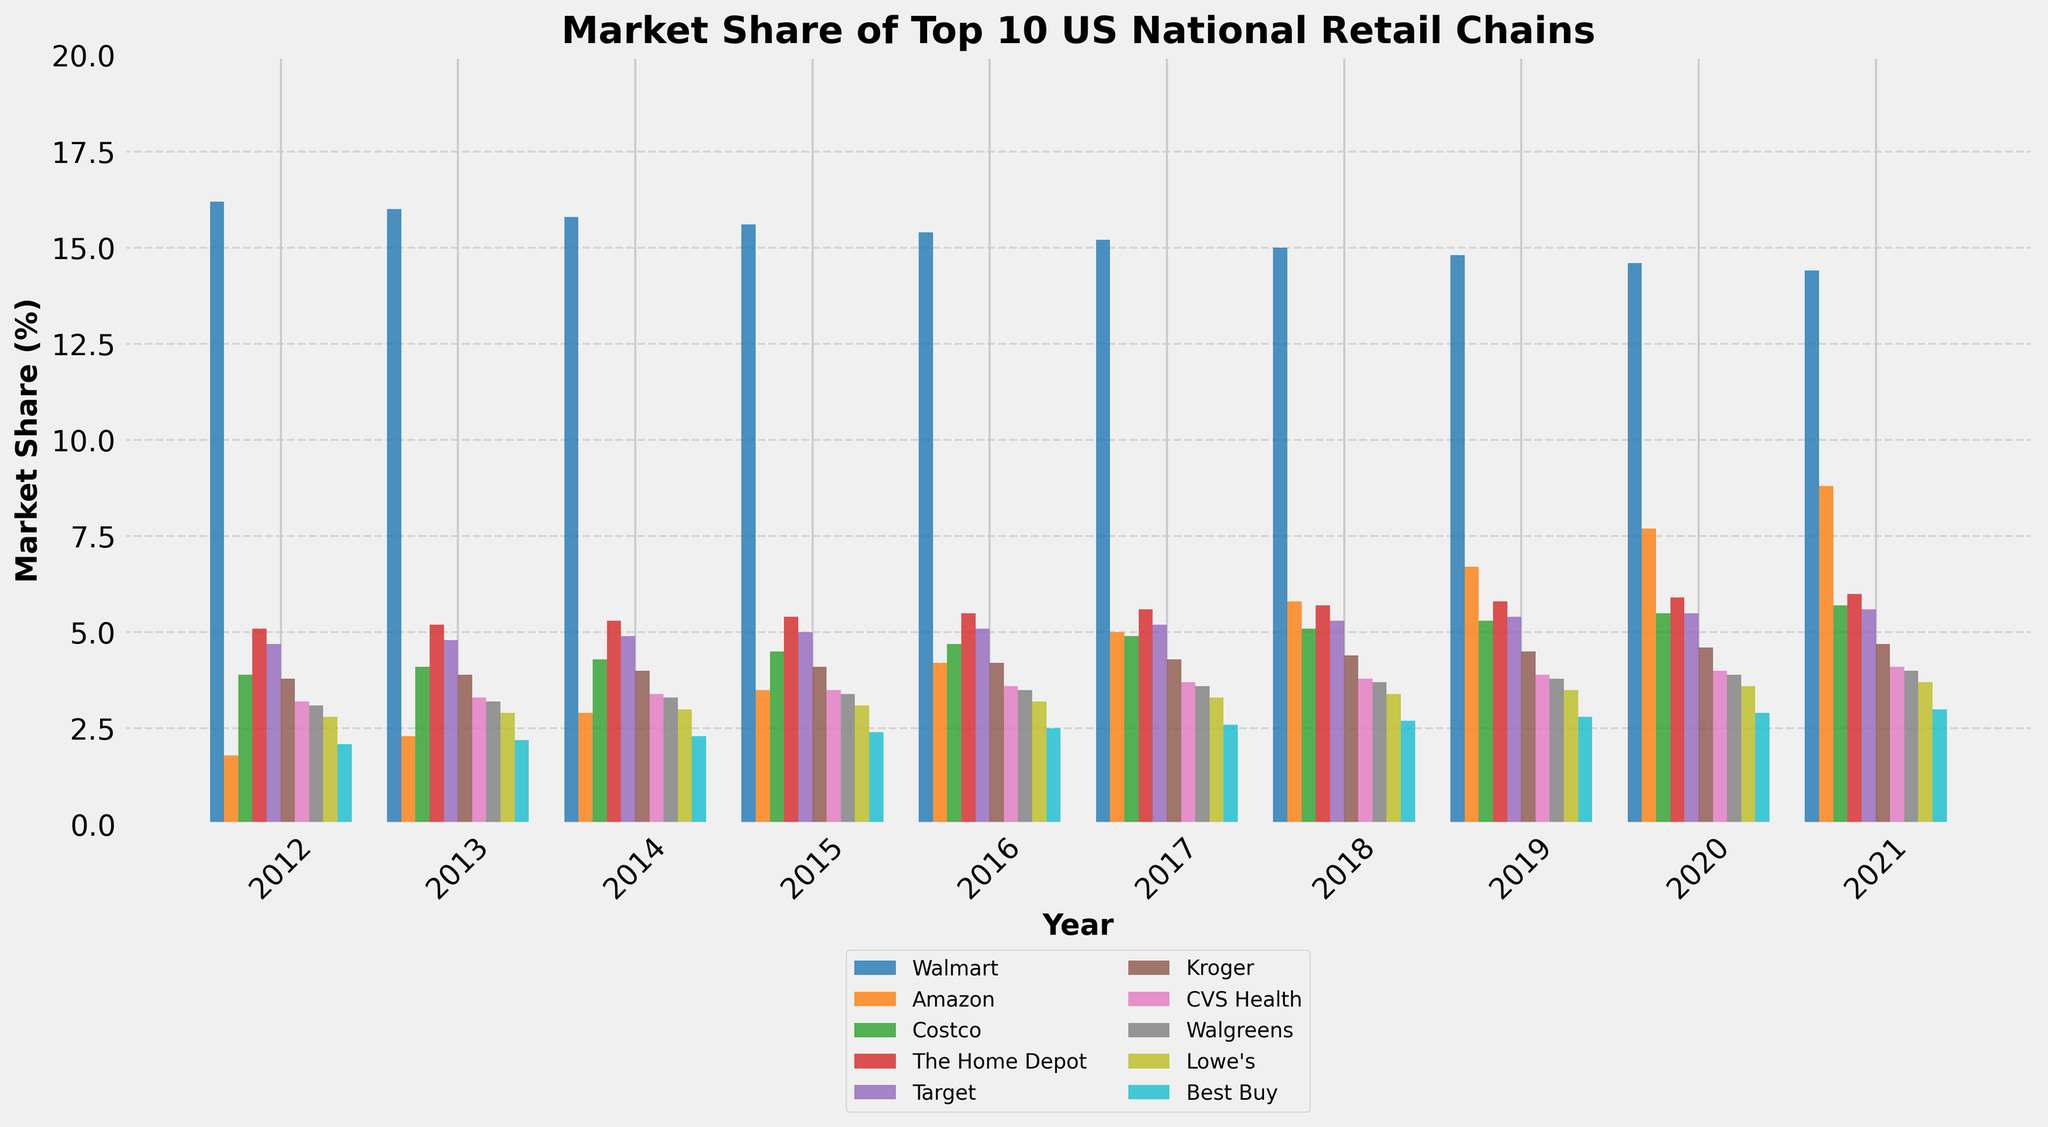What's the market share trend of Amazon from 2012 to 2021? To identify Amazon's trend, observe the height of Amazon's bar for each year and note the changes across the years. Amazon's market share begins at 1.8% in 2012 and steadily rises each year, reaching 8.8% in 2021. This indicates a continuous growth trend.
Answer: Continuous growth Which company had the highest market share every year from 2012 to 2021? Focus on the tallest bar in each stacked set of bars per year. Walmart's bars are consistently the tallest throughout all the years from 2012 to 2021.
Answer: Walmart In 2020, how did the combined market share of CVS Health and Walgreens compare to that of Costco? Locate the bars for CVS Health, Walgreens, and Costco in 2020. CVS Health is 4.0% and Walgreens is 3.9%, summing up to 7.9%. Costco's market share is 5.5%. Thus, the combined shares of CVS Health and Walgreens are higher than Costco's.
Answer: Higher What is the difference in market share between Walmart and Amazon in 2021? Check the bars for Walmart and Amazon in 2021. Walmart's share is 14.4%, and Amazon's is 8.8%. The difference is calculated as 14.4% - 8.8% = 5.6%.
Answer: 5.6% Which company showed a clear, continuous increase in market share every year? Look for the company whose bars consistently increase in height every year. Amazon is the only company that shows a clear, continuous increase in market share each year from 2012 to 2021.
Answer: Amazon How much did the market share of Best Buy change from 2012 to 2021? Note the height of Best Buy's bars in 2012 and 2021. The market share in 2012 is 2.1%, and in 2021 it is 3.0%. The change is 3.0% - 2.1% = 0.9%.
Answer: 0.9% Who had a larger market share in 2016: The Home Depot or Target? Examine the bars for The Home Depot and Target in 2016. The Home Depot's market share is 5.5% and Target's is 5.1%. Thus, The Home Depot had a larger share.
Answer: The Home Depot Which company's market share remained almost constant around 3%? Identify the company whose bars hover around the same height near 3% across the years. Walgreens' bars consistently stay close to the 3% mark from 2012 to 2021.
Answer: Walgreens In 2017, how did the combined market share of Lowe's and Best Buy compare to Kroger? Locate the bars for Lowe's, Best Buy, and Kroger in 2017. Lowe's is 3.3% and Best Buy is 2.6%, summing up to 5.9%. Kroger's market share is 4.3%. Therefore, the combined shares of Lowe's and Best Buy are higher than Kroger's.
Answer: Higher What was the average market share of Target over the decade? Determine Target's market share each year from 2012 to 2021. Sum these values: 4.7% + 4.8% + 4.9% + 5.0% + 5.1% + 5.2% + 5.3% + 5.4% + 5.5% + 5.6% = 51.5%. Divide by the number of years (10). The average is 51.5% / 10 = 5.15%.
Answer: 5.15% 